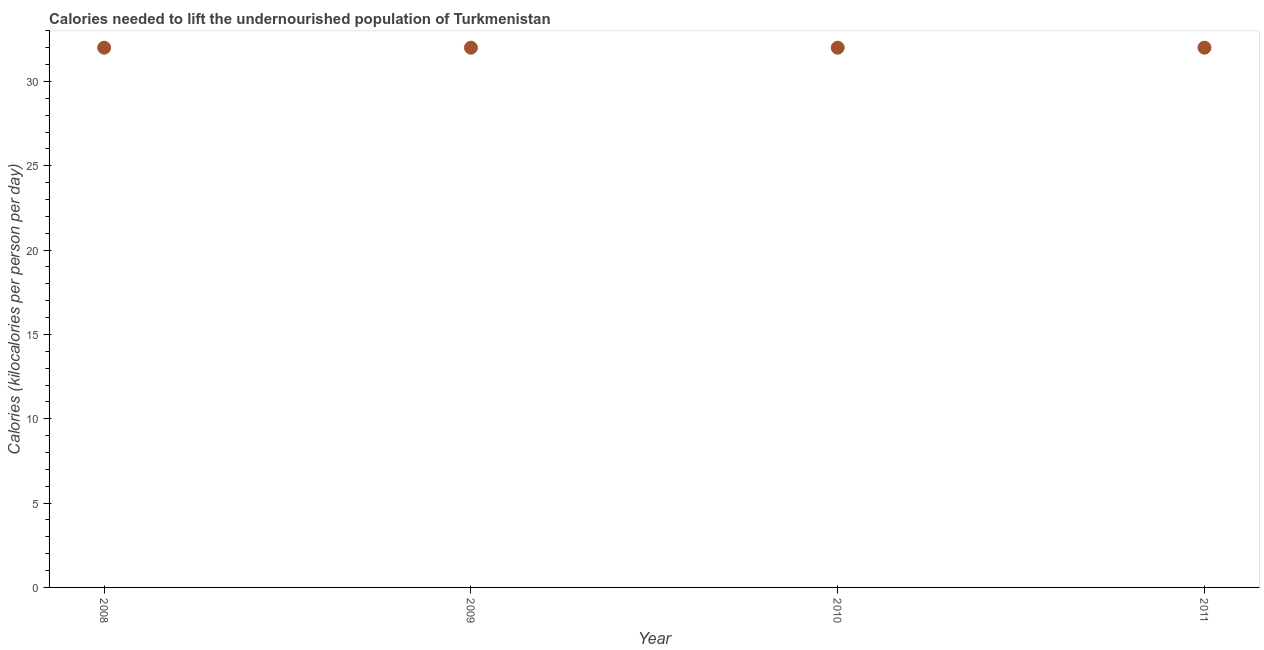What is the depth of food deficit in 2008?
Your answer should be very brief. 32. Across all years, what is the maximum depth of food deficit?
Ensure brevity in your answer.  32. Across all years, what is the minimum depth of food deficit?
Give a very brief answer. 32. In which year was the depth of food deficit minimum?
Give a very brief answer. 2008. What is the sum of the depth of food deficit?
Your answer should be very brief. 128. What is the difference between the depth of food deficit in 2008 and 2010?
Your answer should be very brief. 0. What is the average depth of food deficit per year?
Offer a very short reply. 32. Do a majority of the years between 2009 and 2008 (inclusive) have depth of food deficit greater than 10 kilocalories?
Ensure brevity in your answer.  No. Is the sum of the depth of food deficit in 2009 and 2011 greater than the maximum depth of food deficit across all years?
Give a very brief answer. Yes. What is the difference between the highest and the lowest depth of food deficit?
Provide a short and direct response. 0. Does the depth of food deficit monotonically increase over the years?
Give a very brief answer. No. How many years are there in the graph?
Make the answer very short. 4. What is the title of the graph?
Offer a very short reply. Calories needed to lift the undernourished population of Turkmenistan. What is the label or title of the X-axis?
Offer a terse response. Year. What is the label or title of the Y-axis?
Offer a very short reply. Calories (kilocalories per person per day). What is the difference between the Calories (kilocalories per person per day) in 2008 and 2010?
Provide a short and direct response. 0. What is the difference between the Calories (kilocalories per person per day) in 2008 and 2011?
Your answer should be compact. 0. What is the difference between the Calories (kilocalories per person per day) in 2009 and 2010?
Make the answer very short. 0. What is the difference between the Calories (kilocalories per person per day) in 2009 and 2011?
Your response must be concise. 0. What is the difference between the Calories (kilocalories per person per day) in 2010 and 2011?
Provide a succinct answer. 0. What is the ratio of the Calories (kilocalories per person per day) in 2008 to that in 2010?
Give a very brief answer. 1. 